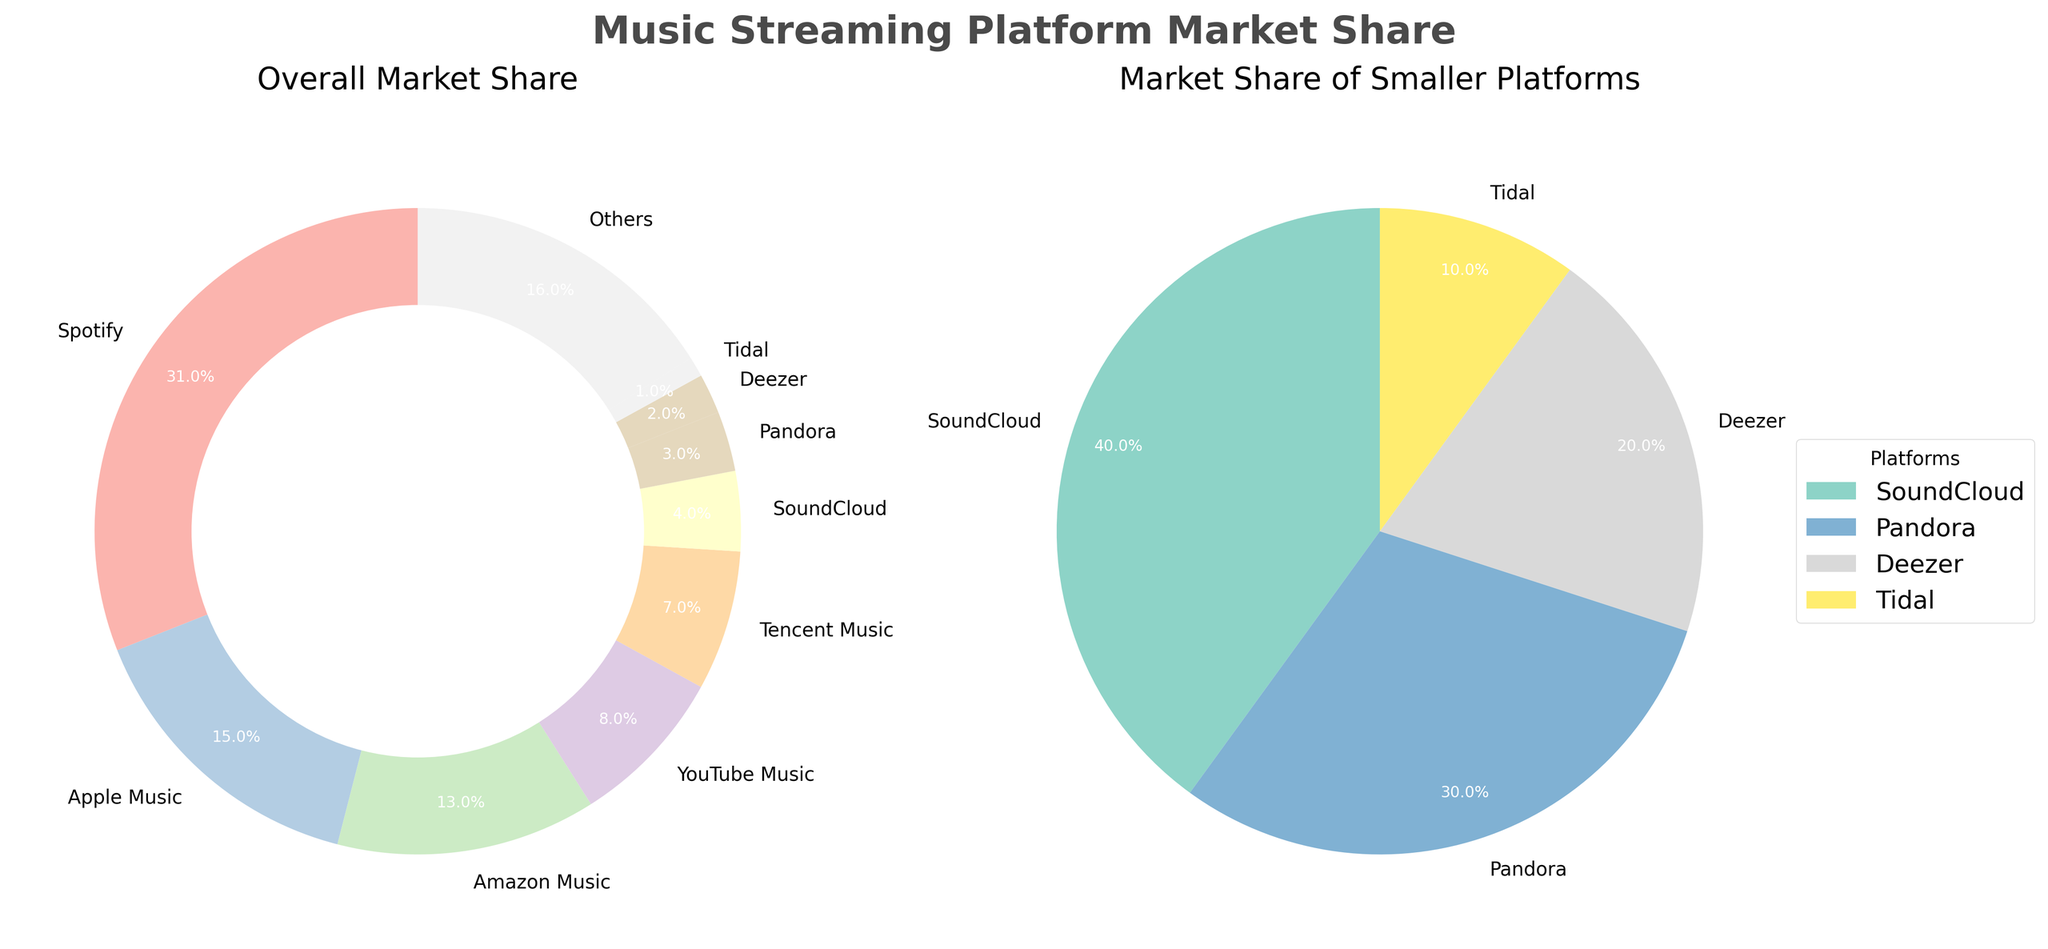What is the market share of Spotify according to the overall pie chart? Look at the section labeled "Spotify" in the overall market share donut chart. The percentage shown is 31%.
Answer: 31% Which platform has the smallest market share, and what is its percentage in the overall pie chart? In the overall market share donut chart, the platform with the smallest section is "Tidal," and its percentage is 1%.
Answer: Tidal, 1% How many platforms have a market share below 5% according to the smaller pie chart? In the smaller pie chart, count the sections. They are labeled SoundCloud, Pandora, Deezer, Tidal, and Others. There are five platforms.
Answer: 5 What is the combined market share of Apple Music and Amazon Music? Refer to the sections labeled "Apple Music" and "Amazon Music" in the overall market share donut chart. Add their percentages: 15% + 13% = 28%.
Answer: 28% Which two platforms have market shares closest to each other, according to the overall pie chart? In the overall market share donut chart, compare the adjacent percentages. Amazon Music and YouTube Music have the closest percentages at 13% and 8%, respectively.
Answer: Amazon Music and YouTube Music What is the cumulative market share of all platforms depicted in the smaller pie chart? Sum the percentages of all the platforms in the smaller pie chart: SoundCloud (4%), Pandora (3%), Deezer (2%), Tidal (1%), Others (16%). Total = 4% + 3% + 2% + 1% + 16% = 26%.
Answer: 26% What platform has the third-largest market share in the overall market? In the overall market share donut chart, the third-largest section is labeled "Amazon Music" with 13%.
Answer: Amazon Music What is the difference in market share between the largest and smallest platforms in the overall pie chart? Identify the largest (Spotify, 31%) and smallest (Tidal, 1%) sections. Subtract the smallest from the largest: 31% - 1% = 30%.
Answer: 30% Which platform has a higher market share: YouTube Music or Tencent Music? Compare the sections labeled "YouTube Music" (8%) and "Tencent Music" (7%) in the overall market share donut chart. YouTube Music has a higher market share.
Answer: YouTube Music How does the cumulative market share of the top two platforms compare to the market share of all platforms below 5%? The top two platforms are Spotify (31%) and Apple Music (15%): 31% + 15% = 46%. Platforms below 5% total 26%. Comparing both: 46% > 26%.
Answer: 46% is greater than 26% 